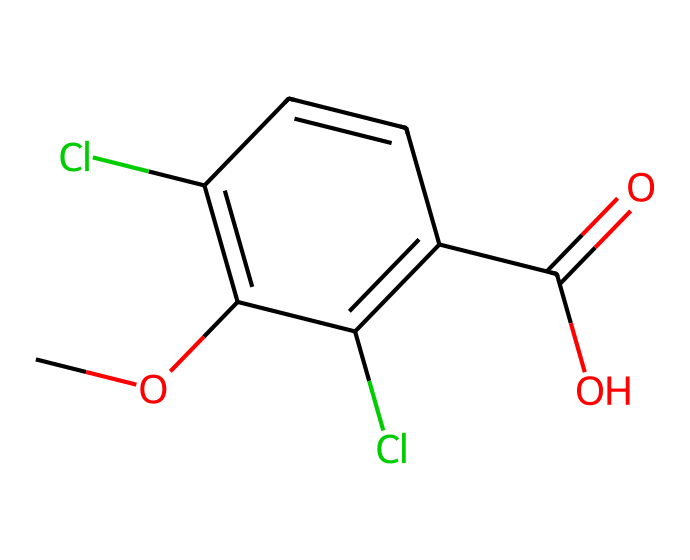What is the molecular formula of dicamba? By analyzing the SMILES representation, we break down the distinct atoms present: 10 carbons (C), 9 hydrogens (H), 2 chlorines (Cl), and 3 oxygens (O). Using this information, we can create the molecular formula: C10H9Cl2O3.
Answer: C10H9Cl2O3 How many chlorine atoms are in dicamba? The SMILES notation shows two 'Cl' symbols, indicating that there are two chlorine atoms present in the structure.
Answer: 2 What functional group is indicated by "C(=O)O" in dicamba? In the SMILES, "C(=O)O" represents a carboxylic acid functional group, where carbon (C) is double-bonded to oxygen (O) and also bonded to a hydroxyl group (O). This confirms the presence of a carboxylic acid in dicamba.
Answer: carboxylic acid What type of herbicide is dicamba primarily used against? Dicamba is known to be effective against broadleaf weeds. The structure contributes to its ability to selectively target these types of plants without affecting grass species.
Answer: broadleaf weeds How many rings are present in the structure of dicamba? Examining the SMILES representation shows that there is a benzene ring structure (indicated by "c1...c...c1"), which signifies that there is one ring in the compound.
Answer: 1 What does the presence of two chlorine substituents suggest about dicamba's properties? The presence of two chlorine atoms typically indicates increased herbicidal activity and stability. It also suggests potential toxicity and environmental persistence, which are relevant in herbicide application.
Answer: increased activity 